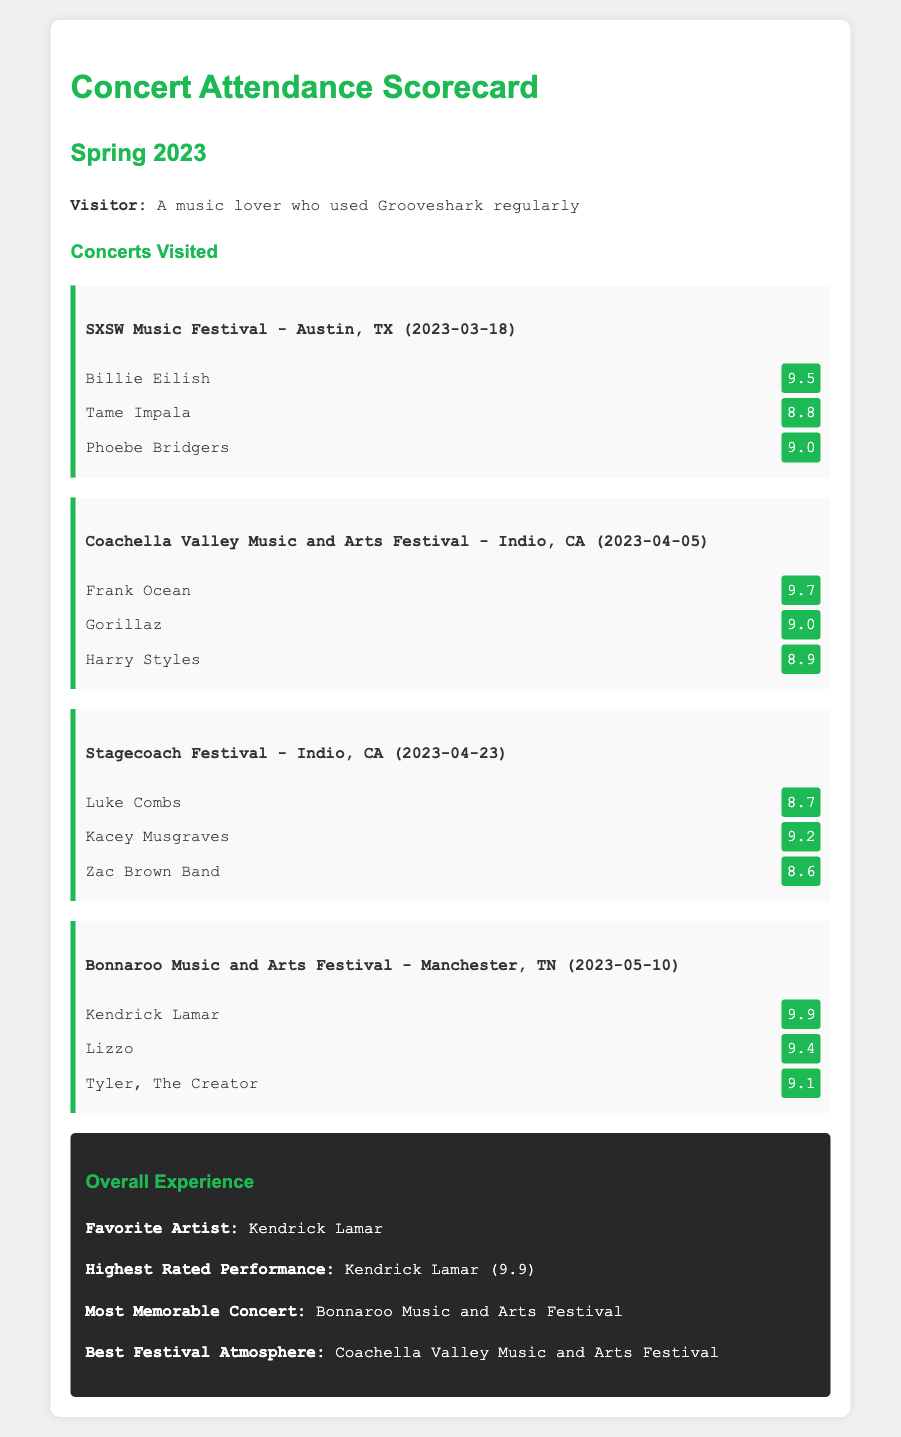What was the date of the SXSW Music Festival? The SXSW Music Festival took place on March 18, 2023.
Answer: March 18, 2023 What is the rating of Billie Eilish's performance? Billie Eilish's performance was rated 9.5.
Answer: 9.5 Which festival had the highest rated performance? The Bonnaroo Music and Arts Festival featured Kendrick Lamar's performance rated 9.9, the highest of all listed.
Answer: Bonnaroo Music and Arts Festival Who performed at the Coachella Valley Music and Arts Festival? The performers included Frank Ocean, Gorillaz, and Harry Styles.
Answer: Frank Ocean, Gorillaz, and Harry Styles What is the favorite artist mentioned in the overall experience? The overall experience lists Kendrick Lamar as the favorite artist.
Answer: Kendrick Lamar What was the rating for Kacey Musgraves at Stagecoach Festival? Kacey Musgraves received a rating of 9.2 at the Stagecoach Festival.
Answer: 9.2 Which artist was rated 9.4 at Bonnaroo? Lizzo was rated 9.4 at the Bonnaroo Music and Arts Festival.
Answer: Lizzo What festival was considered to have the best atmosphere? The document states that the Coachella Valley Music and Arts Festival had the best atmosphere.
Answer: Coachella Valley Music and Arts Festival 